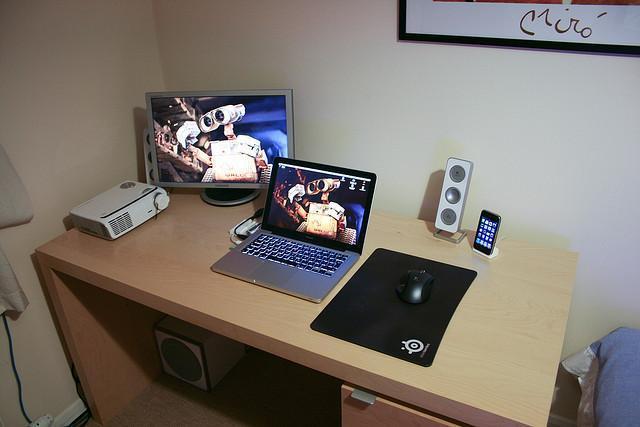How many monitors are on the desk?
Give a very brief answer. 2. How many computer monitors are on the desk?
Give a very brief answer. 2. How many tvs are there?
Give a very brief answer. 1. How many chairs are there?
Give a very brief answer. 0. 